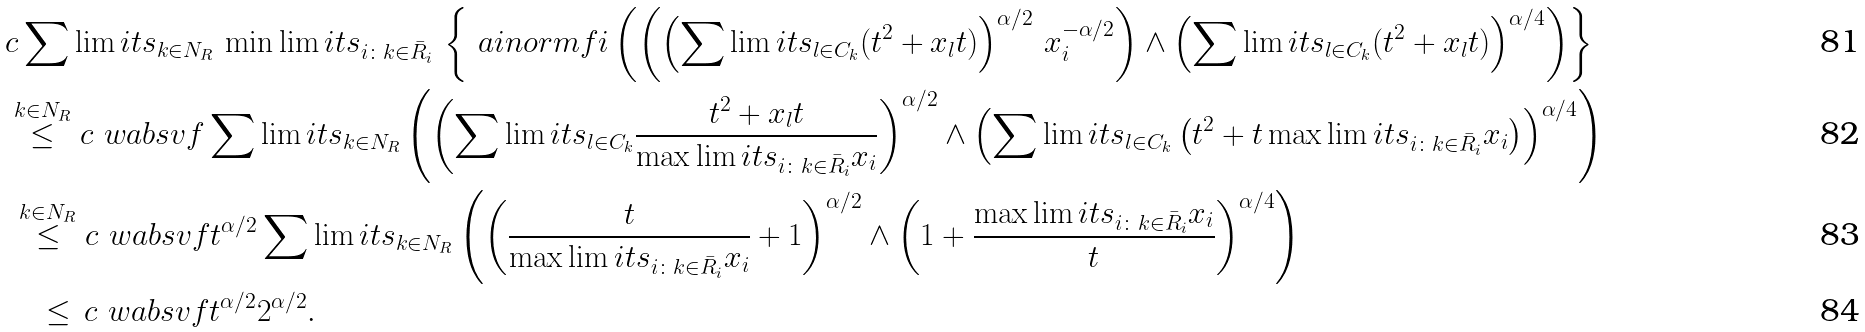<formula> <loc_0><loc_0><loc_500><loc_500>& c \sum \lim i t s _ { k \in N _ { R } } \, \min \lim i t s _ { i \colon k \in \bar { R } _ { i } } \, \left \{ \ a i n o r m { f } { i } \left ( \left ( \left ( \sum \lim i t s _ { l \in C _ { k } } ( t ^ { 2 } + x _ { l } t ) \right ) ^ { \alpha / 2 } \, x _ { i } ^ { - \alpha / 2 } \right ) \wedge \left ( \sum \lim i t s _ { l \in C _ { k } } ( t ^ { 2 } + x _ { l } t ) \right ) ^ { \alpha / 4 } \right ) \right \} \\ & \stackrel { k \in N _ { R } } { \leq } c \ w a b s v { f } \sum \lim i t s _ { k \in N _ { R } } \left ( \left ( \sum \lim i t s _ { l \in C _ { k } } \frac { t ^ { 2 } + x _ { l } t } { \max \lim i t s _ { i \colon k \in \bar { R } _ { i } } x _ { i } } \right ) ^ { \alpha / 2 } \wedge \left ( \sum \lim i t s _ { l \in C _ { k } } \left ( t ^ { 2 } + t \max \lim i t s _ { i \colon k \in \bar { R } _ { i } } x _ { i } \right ) \right ) ^ { \alpha / 4 } \right ) \\ & \, \stackrel { k \in N _ { R } } { \leq } c \ w a b s v { f } t ^ { \alpha / 2 } \sum \lim i t s _ { k \in N _ { R } } \left ( \left ( \frac { t } { \max \lim i t s _ { i \colon k \in \bar { R } _ { i } } x _ { i } } + 1 \right ) ^ { \alpha / 2 } \wedge \left ( 1 + \frac { \max \lim i t s _ { i \colon k \in \bar { R } _ { i } } x _ { i } } { t } \right ) ^ { \alpha / 4 } \right ) \\ & \quad \leq \, c \ w a b s v { f } t ^ { \alpha / 2 } 2 ^ { \alpha / 2 } .</formula> 